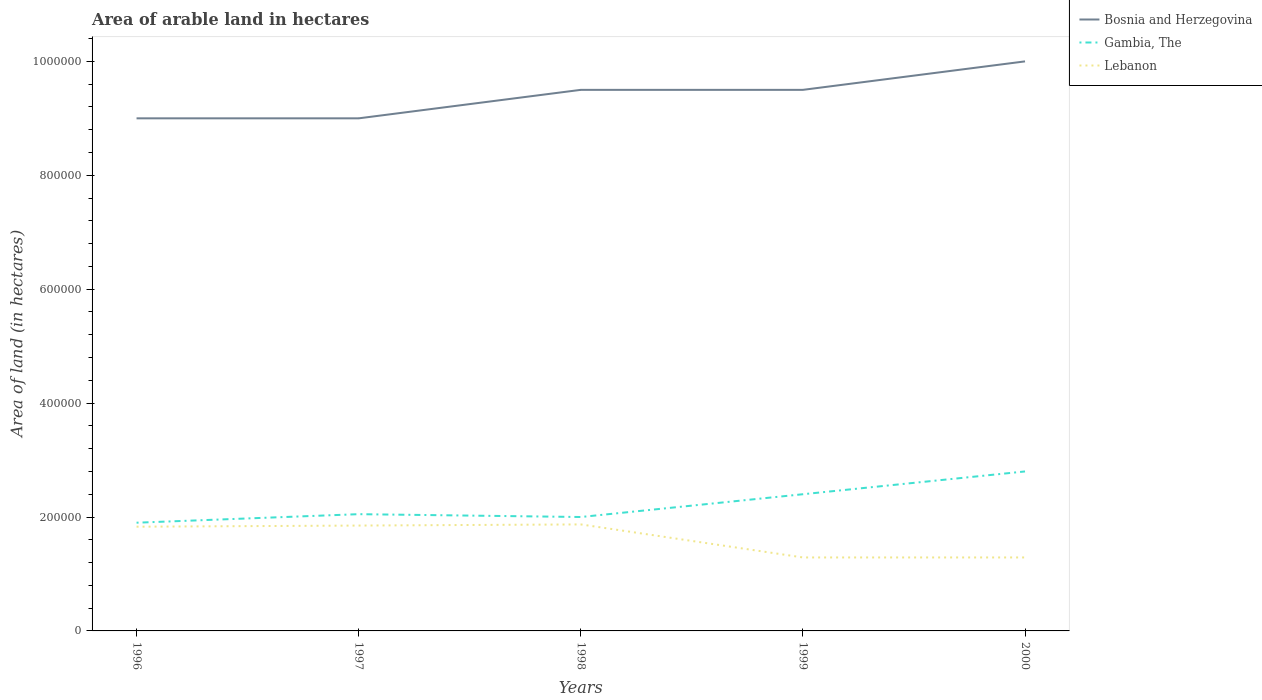How many different coloured lines are there?
Ensure brevity in your answer.  3. Is the number of lines equal to the number of legend labels?
Your response must be concise. Yes. Across all years, what is the maximum total arable land in Gambia, The?
Ensure brevity in your answer.  1.90e+05. In which year was the total arable land in Bosnia and Herzegovina maximum?
Make the answer very short. 1996. What is the difference between the highest and the second highest total arable land in Gambia, The?
Provide a succinct answer. 9.00e+04. What is the difference between the highest and the lowest total arable land in Lebanon?
Your answer should be very brief. 3. Is the total arable land in Lebanon strictly greater than the total arable land in Gambia, The over the years?
Your answer should be very brief. Yes. How many years are there in the graph?
Offer a terse response. 5. Are the values on the major ticks of Y-axis written in scientific E-notation?
Your answer should be very brief. No. Where does the legend appear in the graph?
Ensure brevity in your answer.  Top right. How many legend labels are there?
Your answer should be very brief. 3. How are the legend labels stacked?
Keep it short and to the point. Vertical. What is the title of the graph?
Give a very brief answer. Area of arable land in hectares. Does "Malta" appear as one of the legend labels in the graph?
Provide a succinct answer. No. What is the label or title of the X-axis?
Your answer should be very brief. Years. What is the label or title of the Y-axis?
Provide a short and direct response. Area of land (in hectares). What is the Area of land (in hectares) in Bosnia and Herzegovina in 1996?
Give a very brief answer. 9.00e+05. What is the Area of land (in hectares) of Gambia, The in 1996?
Your answer should be very brief. 1.90e+05. What is the Area of land (in hectares) in Lebanon in 1996?
Make the answer very short. 1.83e+05. What is the Area of land (in hectares) of Gambia, The in 1997?
Make the answer very short. 2.05e+05. What is the Area of land (in hectares) in Lebanon in 1997?
Your answer should be very brief. 1.85e+05. What is the Area of land (in hectares) of Bosnia and Herzegovina in 1998?
Keep it short and to the point. 9.50e+05. What is the Area of land (in hectares) of Gambia, The in 1998?
Offer a terse response. 2.00e+05. What is the Area of land (in hectares) of Lebanon in 1998?
Provide a succinct answer. 1.87e+05. What is the Area of land (in hectares) of Bosnia and Herzegovina in 1999?
Offer a very short reply. 9.50e+05. What is the Area of land (in hectares) of Lebanon in 1999?
Offer a terse response. 1.29e+05. What is the Area of land (in hectares) in Gambia, The in 2000?
Your answer should be very brief. 2.80e+05. What is the Area of land (in hectares) of Lebanon in 2000?
Give a very brief answer. 1.29e+05. Across all years, what is the maximum Area of land (in hectares) of Lebanon?
Give a very brief answer. 1.87e+05. Across all years, what is the minimum Area of land (in hectares) in Bosnia and Herzegovina?
Your response must be concise. 9.00e+05. Across all years, what is the minimum Area of land (in hectares) of Lebanon?
Keep it short and to the point. 1.29e+05. What is the total Area of land (in hectares) of Bosnia and Herzegovina in the graph?
Your answer should be very brief. 4.70e+06. What is the total Area of land (in hectares) in Gambia, The in the graph?
Offer a very short reply. 1.12e+06. What is the total Area of land (in hectares) of Lebanon in the graph?
Offer a very short reply. 8.13e+05. What is the difference between the Area of land (in hectares) of Gambia, The in 1996 and that in 1997?
Offer a terse response. -1.50e+04. What is the difference between the Area of land (in hectares) in Lebanon in 1996 and that in 1997?
Offer a terse response. -2000. What is the difference between the Area of land (in hectares) in Lebanon in 1996 and that in 1998?
Your response must be concise. -4000. What is the difference between the Area of land (in hectares) of Bosnia and Herzegovina in 1996 and that in 1999?
Give a very brief answer. -5.00e+04. What is the difference between the Area of land (in hectares) of Gambia, The in 1996 and that in 1999?
Your response must be concise. -5.00e+04. What is the difference between the Area of land (in hectares) in Lebanon in 1996 and that in 1999?
Your response must be concise. 5.40e+04. What is the difference between the Area of land (in hectares) in Lebanon in 1996 and that in 2000?
Your answer should be very brief. 5.40e+04. What is the difference between the Area of land (in hectares) in Bosnia and Herzegovina in 1997 and that in 1998?
Offer a terse response. -5.00e+04. What is the difference between the Area of land (in hectares) in Lebanon in 1997 and that in 1998?
Ensure brevity in your answer.  -2000. What is the difference between the Area of land (in hectares) of Gambia, The in 1997 and that in 1999?
Provide a succinct answer. -3.50e+04. What is the difference between the Area of land (in hectares) of Lebanon in 1997 and that in 1999?
Provide a succinct answer. 5.60e+04. What is the difference between the Area of land (in hectares) in Gambia, The in 1997 and that in 2000?
Ensure brevity in your answer.  -7.50e+04. What is the difference between the Area of land (in hectares) of Lebanon in 1997 and that in 2000?
Your response must be concise. 5.60e+04. What is the difference between the Area of land (in hectares) in Gambia, The in 1998 and that in 1999?
Offer a very short reply. -4.00e+04. What is the difference between the Area of land (in hectares) in Lebanon in 1998 and that in 1999?
Ensure brevity in your answer.  5.80e+04. What is the difference between the Area of land (in hectares) in Bosnia and Herzegovina in 1998 and that in 2000?
Give a very brief answer. -5.00e+04. What is the difference between the Area of land (in hectares) of Lebanon in 1998 and that in 2000?
Your response must be concise. 5.80e+04. What is the difference between the Area of land (in hectares) of Gambia, The in 1999 and that in 2000?
Your answer should be very brief. -4.00e+04. What is the difference between the Area of land (in hectares) in Bosnia and Herzegovina in 1996 and the Area of land (in hectares) in Gambia, The in 1997?
Keep it short and to the point. 6.95e+05. What is the difference between the Area of land (in hectares) in Bosnia and Herzegovina in 1996 and the Area of land (in hectares) in Lebanon in 1997?
Give a very brief answer. 7.15e+05. What is the difference between the Area of land (in hectares) in Bosnia and Herzegovina in 1996 and the Area of land (in hectares) in Lebanon in 1998?
Keep it short and to the point. 7.13e+05. What is the difference between the Area of land (in hectares) in Gambia, The in 1996 and the Area of land (in hectares) in Lebanon in 1998?
Ensure brevity in your answer.  3000. What is the difference between the Area of land (in hectares) in Bosnia and Herzegovina in 1996 and the Area of land (in hectares) in Lebanon in 1999?
Ensure brevity in your answer.  7.71e+05. What is the difference between the Area of land (in hectares) of Gambia, The in 1996 and the Area of land (in hectares) of Lebanon in 1999?
Offer a terse response. 6.10e+04. What is the difference between the Area of land (in hectares) in Bosnia and Herzegovina in 1996 and the Area of land (in hectares) in Gambia, The in 2000?
Your answer should be very brief. 6.20e+05. What is the difference between the Area of land (in hectares) in Bosnia and Herzegovina in 1996 and the Area of land (in hectares) in Lebanon in 2000?
Your response must be concise. 7.71e+05. What is the difference between the Area of land (in hectares) of Gambia, The in 1996 and the Area of land (in hectares) of Lebanon in 2000?
Your answer should be compact. 6.10e+04. What is the difference between the Area of land (in hectares) in Bosnia and Herzegovina in 1997 and the Area of land (in hectares) in Lebanon in 1998?
Make the answer very short. 7.13e+05. What is the difference between the Area of land (in hectares) of Gambia, The in 1997 and the Area of land (in hectares) of Lebanon in 1998?
Provide a succinct answer. 1.80e+04. What is the difference between the Area of land (in hectares) in Bosnia and Herzegovina in 1997 and the Area of land (in hectares) in Gambia, The in 1999?
Make the answer very short. 6.60e+05. What is the difference between the Area of land (in hectares) in Bosnia and Herzegovina in 1997 and the Area of land (in hectares) in Lebanon in 1999?
Your answer should be very brief. 7.71e+05. What is the difference between the Area of land (in hectares) of Gambia, The in 1997 and the Area of land (in hectares) of Lebanon in 1999?
Your answer should be compact. 7.60e+04. What is the difference between the Area of land (in hectares) in Bosnia and Herzegovina in 1997 and the Area of land (in hectares) in Gambia, The in 2000?
Provide a short and direct response. 6.20e+05. What is the difference between the Area of land (in hectares) of Bosnia and Herzegovina in 1997 and the Area of land (in hectares) of Lebanon in 2000?
Your answer should be very brief. 7.71e+05. What is the difference between the Area of land (in hectares) in Gambia, The in 1997 and the Area of land (in hectares) in Lebanon in 2000?
Ensure brevity in your answer.  7.60e+04. What is the difference between the Area of land (in hectares) in Bosnia and Herzegovina in 1998 and the Area of land (in hectares) in Gambia, The in 1999?
Your answer should be compact. 7.10e+05. What is the difference between the Area of land (in hectares) of Bosnia and Herzegovina in 1998 and the Area of land (in hectares) of Lebanon in 1999?
Offer a very short reply. 8.21e+05. What is the difference between the Area of land (in hectares) of Gambia, The in 1998 and the Area of land (in hectares) of Lebanon in 1999?
Your response must be concise. 7.10e+04. What is the difference between the Area of land (in hectares) of Bosnia and Herzegovina in 1998 and the Area of land (in hectares) of Gambia, The in 2000?
Your answer should be compact. 6.70e+05. What is the difference between the Area of land (in hectares) in Bosnia and Herzegovina in 1998 and the Area of land (in hectares) in Lebanon in 2000?
Give a very brief answer. 8.21e+05. What is the difference between the Area of land (in hectares) in Gambia, The in 1998 and the Area of land (in hectares) in Lebanon in 2000?
Offer a very short reply. 7.10e+04. What is the difference between the Area of land (in hectares) of Bosnia and Herzegovina in 1999 and the Area of land (in hectares) of Gambia, The in 2000?
Offer a very short reply. 6.70e+05. What is the difference between the Area of land (in hectares) in Bosnia and Herzegovina in 1999 and the Area of land (in hectares) in Lebanon in 2000?
Keep it short and to the point. 8.21e+05. What is the difference between the Area of land (in hectares) of Gambia, The in 1999 and the Area of land (in hectares) of Lebanon in 2000?
Provide a succinct answer. 1.11e+05. What is the average Area of land (in hectares) in Bosnia and Herzegovina per year?
Offer a very short reply. 9.40e+05. What is the average Area of land (in hectares) in Gambia, The per year?
Your answer should be very brief. 2.23e+05. What is the average Area of land (in hectares) in Lebanon per year?
Make the answer very short. 1.63e+05. In the year 1996, what is the difference between the Area of land (in hectares) in Bosnia and Herzegovina and Area of land (in hectares) in Gambia, The?
Provide a short and direct response. 7.10e+05. In the year 1996, what is the difference between the Area of land (in hectares) of Bosnia and Herzegovina and Area of land (in hectares) of Lebanon?
Provide a short and direct response. 7.17e+05. In the year 1996, what is the difference between the Area of land (in hectares) in Gambia, The and Area of land (in hectares) in Lebanon?
Keep it short and to the point. 7000. In the year 1997, what is the difference between the Area of land (in hectares) in Bosnia and Herzegovina and Area of land (in hectares) in Gambia, The?
Provide a succinct answer. 6.95e+05. In the year 1997, what is the difference between the Area of land (in hectares) in Bosnia and Herzegovina and Area of land (in hectares) in Lebanon?
Offer a terse response. 7.15e+05. In the year 1997, what is the difference between the Area of land (in hectares) of Gambia, The and Area of land (in hectares) of Lebanon?
Your response must be concise. 2.00e+04. In the year 1998, what is the difference between the Area of land (in hectares) of Bosnia and Herzegovina and Area of land (in hectares) of Gambia, The?
Offer a terse response. 7.50e+05. In the year 1998, what is the difference between the Area of land (in hectares) of Bosnia and Herzegovina and Area of land (in hectares) of Lebanon?
Keep it short and to the point. 7.63e+05. In the year 1998, what is the difference between the Area of land (in hectares) in Gambia, The and Area of land (in hectares) in Lebanon?
Give a very brief answer. 1.30e+04. In the year 1999, what is the difference between the Area of land (in hectares) in Bosnia and Herzegovina and Area of land (in hectares) in Gambia, The?
Make the answer very short. 7.10e+05. In the year 1999, what is the difference between the Area of land (in hectares) in Bosnia and Herzegovina and Area of land (in hectares) in Lebanon?
Ensure brevity in your answer.  8.21e+05. In the year 1999, what is the difference between the Area of land (in hectares) in Gambia, The and Area of land (in hectares) in Lebanon?
Offer a terse response. 1.11e+05. In the year 2000, what is the difference between the Area of land (in hectares) of Bosnia and Herzegovina and Area of land (in hectares) of Gambia, The?
Offer a terse response. 7.20e+05. In the year 2000, what is the difference between the Area of land (in hectares) of Bosnia and Herzegovina and Area of land (in hectares) of Lebanon?
Offer a very short reply. 8.71e+05. In the year 2000, what is the difference between the Area of land (in hectares) in Gambia, The and Area of land (in hectares) in Lebanon?
Make the answer very short. 1.51e+05. What is the ratio of the Area of land (in hectares) in Gambia, The in 1996 to that in 1997?
Ensure brevity in your answer.  0.93. What is the ratio of the Area of land (in hectares) in Bosnia and Herzegovina in 1996 to that in 1998?
Make the answer very short. 0.95. What is the ratio of the Area of land (in hectares) in Lebanon in 1996 to that in 1998?
Provide a succinct answer. 0.98. What is the ratio of the Area of land (in hectares) of Gambia, The in 1996 to that in 1999?
Your answer should be very brief. 0.79. What is the ratio of the Area of land (in hectares) in Lebanon in 1996 to that in 1999?
Your answer should be very brief. 1.42. What is the ratio of the Area of land (in hectares) of Gambia, The in 1996 to that in 2000?
Make the answer very short. 0.68. What is the ratio of the Area of land (in hectares) in Lebanon in 1996 to that in 2000?
Offer a very short reply. 1.42. What is the ratio of the Area of land (in hectares) of Gambia, The in 1997 to that in 1998?
Give a very brief answer. 1.02. What is the ratio of the Area of land (in hectares) in Lebanon in 1997 to that in 1998?
Ensure brevity in your answer.  0.99. What is the ratio of the Area of land (in hectares) in Bosnia and Herzegovina in 1997 to that in 1999?
Your response must be concise. 0.95. What is the ratio of the Area of land (in hectares) of Gambia, The in 1997 to that in 1999?
Your answer should be compact. 0.85. What is the ratio of the Area of land (in hectares) in Lebanon in 1997 to that in 1999?
Your answer should be very brief. 1.43. What is the ratio of the Area of land (in hectares) in Bosnia and Herzegovina in 1997 to that in 2000?
Make the answer very short. 0.9. What is the ratio of the Area of land (in hectares) in Gambia, The in 1997 to that in 2000?
Keep it short and to the point. 0.73. What is the ratio of the Area of land (in hectares) of Lebanon in 1997 to that in 2000?
Give a very brief answer. 1.43. What is the ratio of the Area of land (in hectares) in Lebanon in 1998 to that in 1999?
Give a very brief answer. 1.45. What is the ratio of the Area of land (in hectares) of Lebanon in 1998 to that in 2000?
Keep it short and to the point. 1.45. What is the ratio of the Area of land (in hectares) in Bosnia and Herzegovina in 1999 to that in 2000?
Provide a short and direct response. 0.95. What is the ratio of the Area of land (in hectares) of Lebanon in 1999 to that in 2000?
Ensure brevity in your answer.  1. What is the difference between the highest and the second highest Area of land (in hectares) of Bosnia and Herzegovina?
Make the answer very short. 5.00e+04. What is the difference between the highest and the second highest Area of land (in hectares) in Lebanon?
Provide a short and direct response. 2000. What is the difference between the highest and the lowest Area of land (in hectares) of Bosnia and Herzegovina?
Make the answer very short. 1.00e+05. What is the difference between the highest and the lowest Area of land (in hectares) of Gambia, The?
Your answer should be very brief. 9.00e+04. What is the difference between the highest and the lowest Area of land (in hectares) of Lebanon?
Provide a short and direct response. 5.80e+04. 